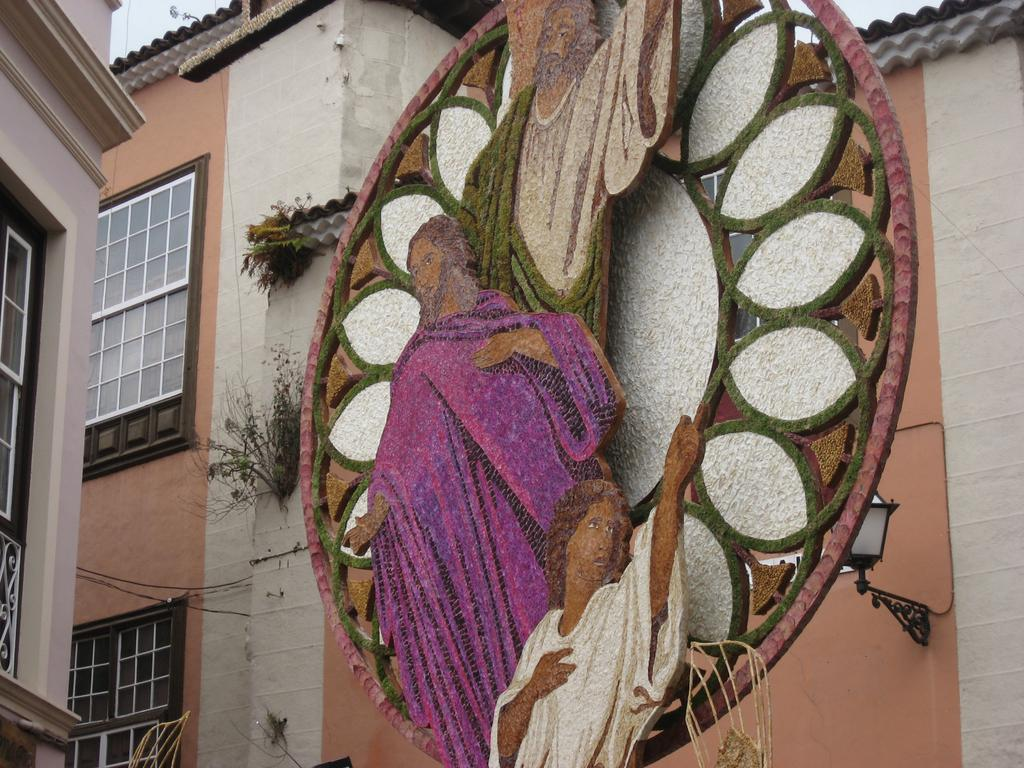What is the main subject in the center of the image? There is a decor in the center of the image. What can be seen in the background of the image? There is a building, a lamp, a wall, bushes, and the sky visible in the background of the image. What type of teaching is being conducted in the image? There is no teaching or educational activity depicted in the image. 